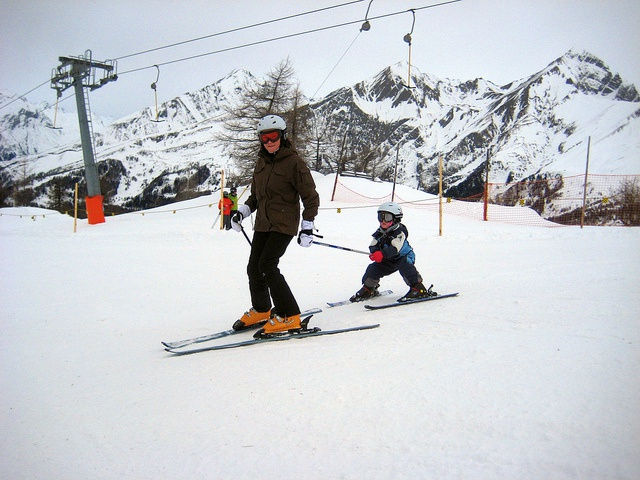Describe the objects in this image and their specific colors. I can see people in darkgray, black, lightgray, and gray tones, people in darkgray, black, gray, lightgray, and navy tones, skis in darkgray, lightgray, gray, and black tones, skis in darkgray, black, lightgray, and gray tones, and people in darkgray, black, darkgreen, olive, and gray tones in this image. 